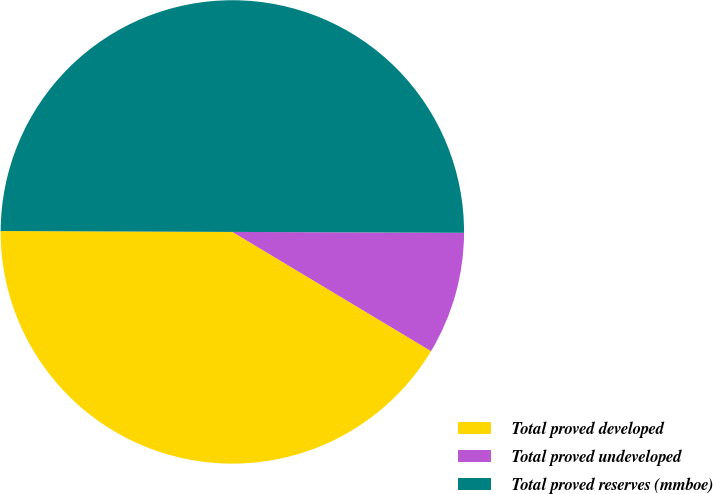Convert chart. <chart><loc_0><loc_0><loc_500><loc_500><pie_chart><fcel>Total proved developed<fcel>Total proved undeveloped<fcel>Total proved reserves (mmboe)<nl><fcel>41.46%<fcel>8.54%<fcel>50.0%<nl></chart> 